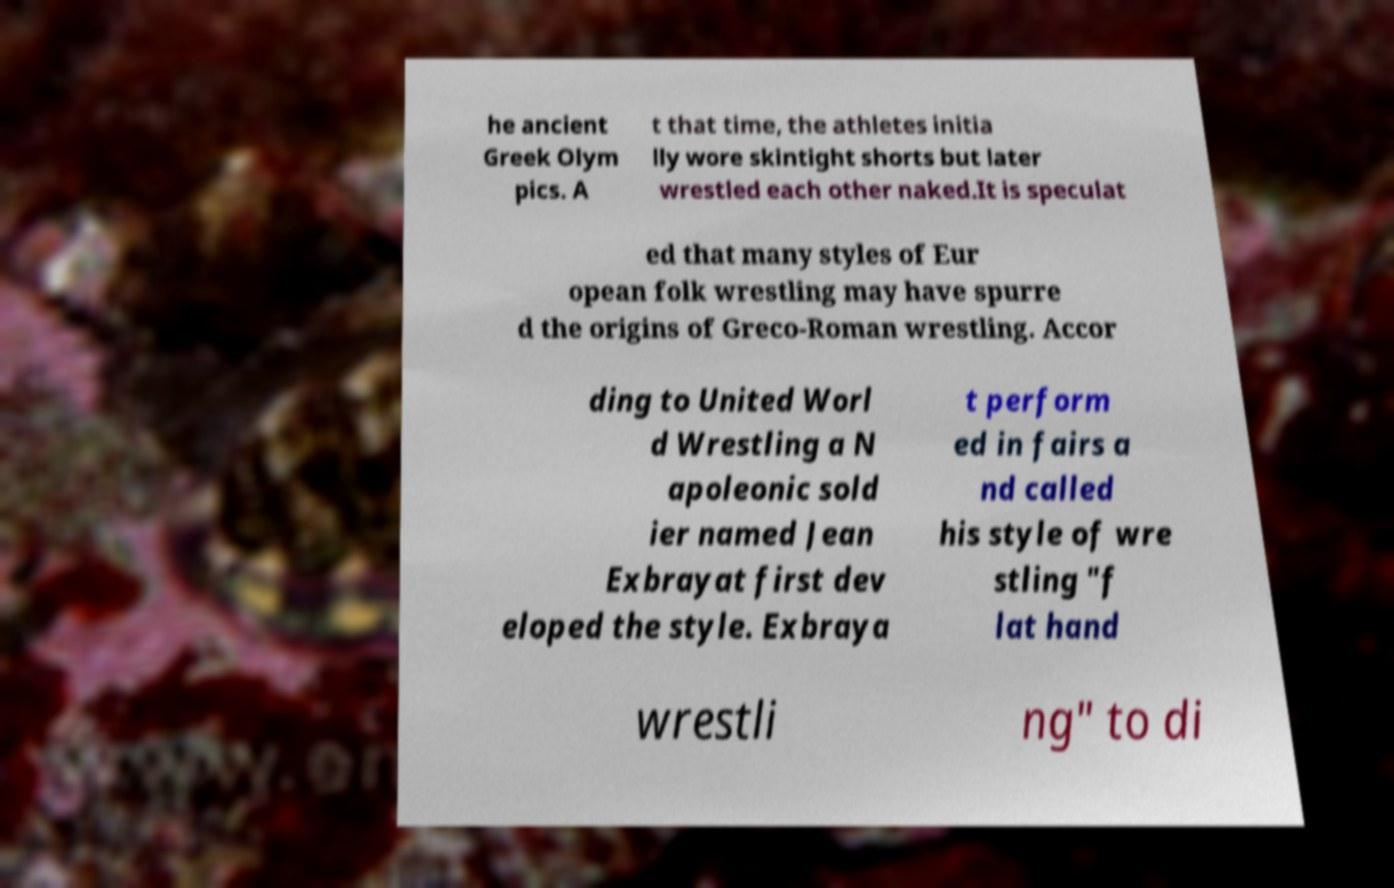Can you read and provide the text displayed in the image?This photo seems to have some interesting text. Can you extract and type it out for me? he ancient Greek Olym pics. A t that time, the athletes initia lly wore skintight shorts but later wrestled each other naked.It is speculat ed that many styles of Eur opean folk wrestling may have spurre d the origins of Greco-Roman wrestling. Accor ding to United Worl d Wrestling a N apoleonic sold ier named Jean Exbrayat first dev eloped the style. Exbraya t perform ed in fairs a nd called his style of wre stling "f lat hand wrestli ng" to di 